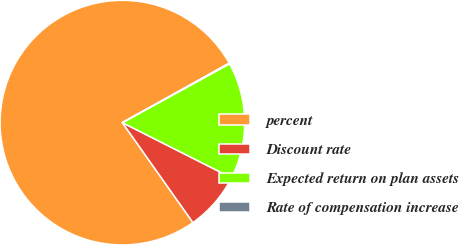<chart> <loc_0><loc_0><loc_500><loc_500><pie_chart><fcel>percent<fcel>Discount rate<fcel>Expected return on plan assets<fcel>Rate of compensation increase<nl><fcel>76.7%<fcel>7.77%<fcel>15.43%<fcel>0.1%<nl></chart> 